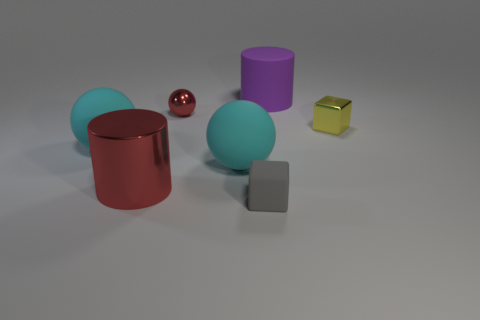Subtract all tiny spheres. How many spheres are left? 2 Add 3 tiny red shiny things. How many objects exist? 10 Subtract all gray cylinders. How many cyan balls are left? 2 Subtract all cyan spheres. How many spheres are left? 1 Subtract all spheres. How many objects are left? 4 Subtract 2 balls. How many balls are left? 1 Subtract all purple balls. Subtract all blue cylinders. How many balls are left? 3 Subtract all big cyan metallic objects. Subtract all tiny cubes. How many objects are left? 5 Add 1 objects. How many objects are left? 8 Add 3 cyan spheres. How many cyan spheres exist? 5 